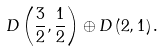Convert formula to latex. <formula><loc_0><loc_0><loc_500><loc_500>D \left ( \frac { 3 } { 2 } , \frac { 1 } { 2 } \right ) \oplus D \left ( 2 , 1 \right ) .</formula> 